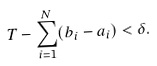<formula> <loc_0><loc_0><loc_500><loc_500>T - \sum _ { i = 1 } ^ { N } ( b _ { i } - a _ { i } ) < \delta .</formula> 